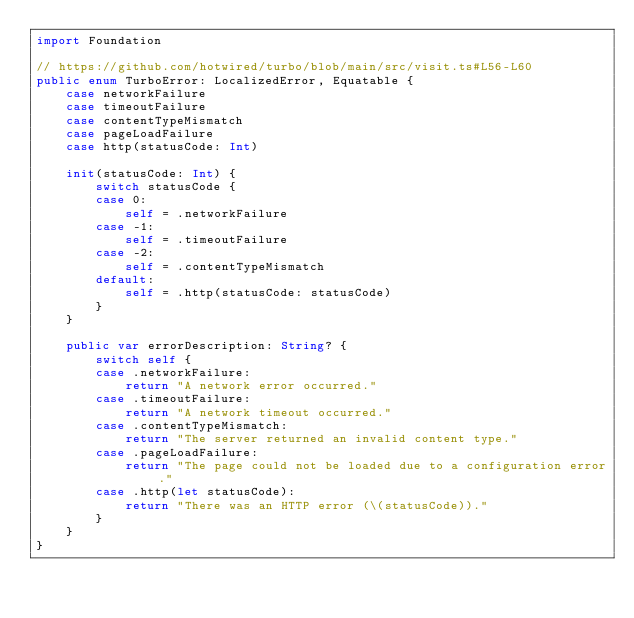<code> <loc_0><loc_0><loc_500><loc_500><_Swift_>import Foundation

// https://github.com/hotwired/turbo/blob/main/src/visit.ts#L56-L60
public enum TurboError: LocalizedError, Equatable {
    case networkFailure
    case timeoutFailure
    case contentTypeMismatch
    case pageLoadFailure
    case http(statusCode: Int)
    
    init(statusCode: Int) {
        switch statusCode {
        case 0:
            self = .networkFailure
        case -1:
            self = .timeoutFailure
        case -2:
            self = .contentTypeMismatch
        default:
            self = .http(statusCode: statusCode)
        }
    }
    
    public var errorDescription: String? {
        switch self {
        case .networkFailure:
            return "A network error occurred."
        case .timeoutFailure:
            return "A network timeout occurred."
        case .contentTypeMismatch:
            return "The server returned an invalid content type."
        case .pageLoadFailure:
            return "The page could not be loaded due to a configuration error."
        case .http(let statusCode):
            return "There was an HTTP error (\(statusCode))."
        }
    }
}
</code> 